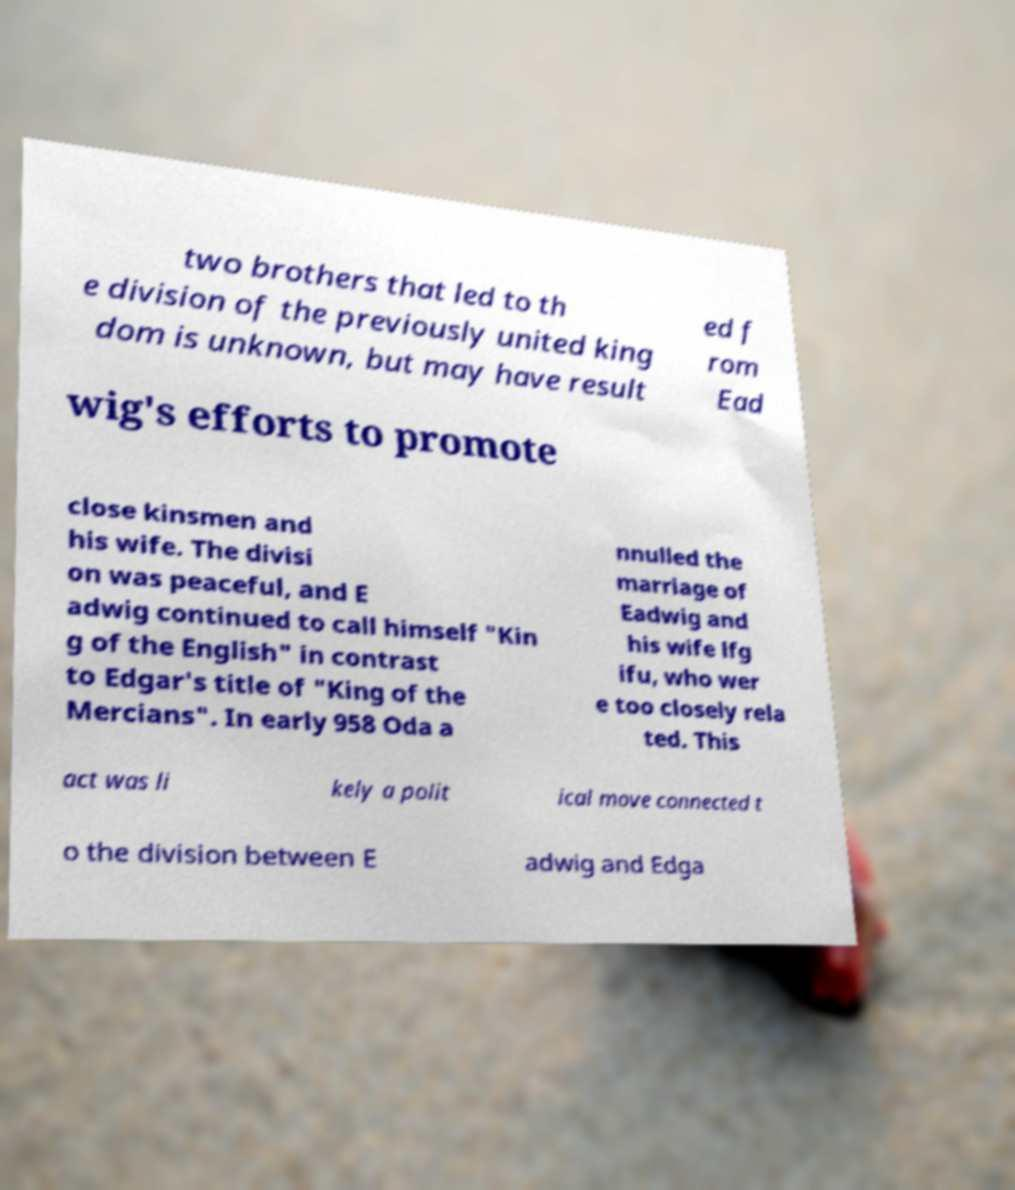What messages or text are displayed in this image? I need them in a readable, typed format. two brothers that led to th e division of the previously united king dom is unknown, but may have result ed f rom Ead wig's efforts to promote close kinsmen and his wife. The divisi on was peaceful, and E adwig continued to call himself "Kin g of the English" in contrast to Edgar's title of "King of the Mercians". In early 958 Oda a nnulled the marriage of Eadwig and his wife lfg ifu, who wer e too closely rela ted. This act was li kely a polit ical move connected t o the division between E adwig and Edga 